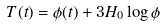Convert formula to latex. <formula><loc_0><loc_0><loc_500><loc_500>T ( t ) = { \phi } ( t ) + 3 H _ { 0 } \log { \phi }</formula> 